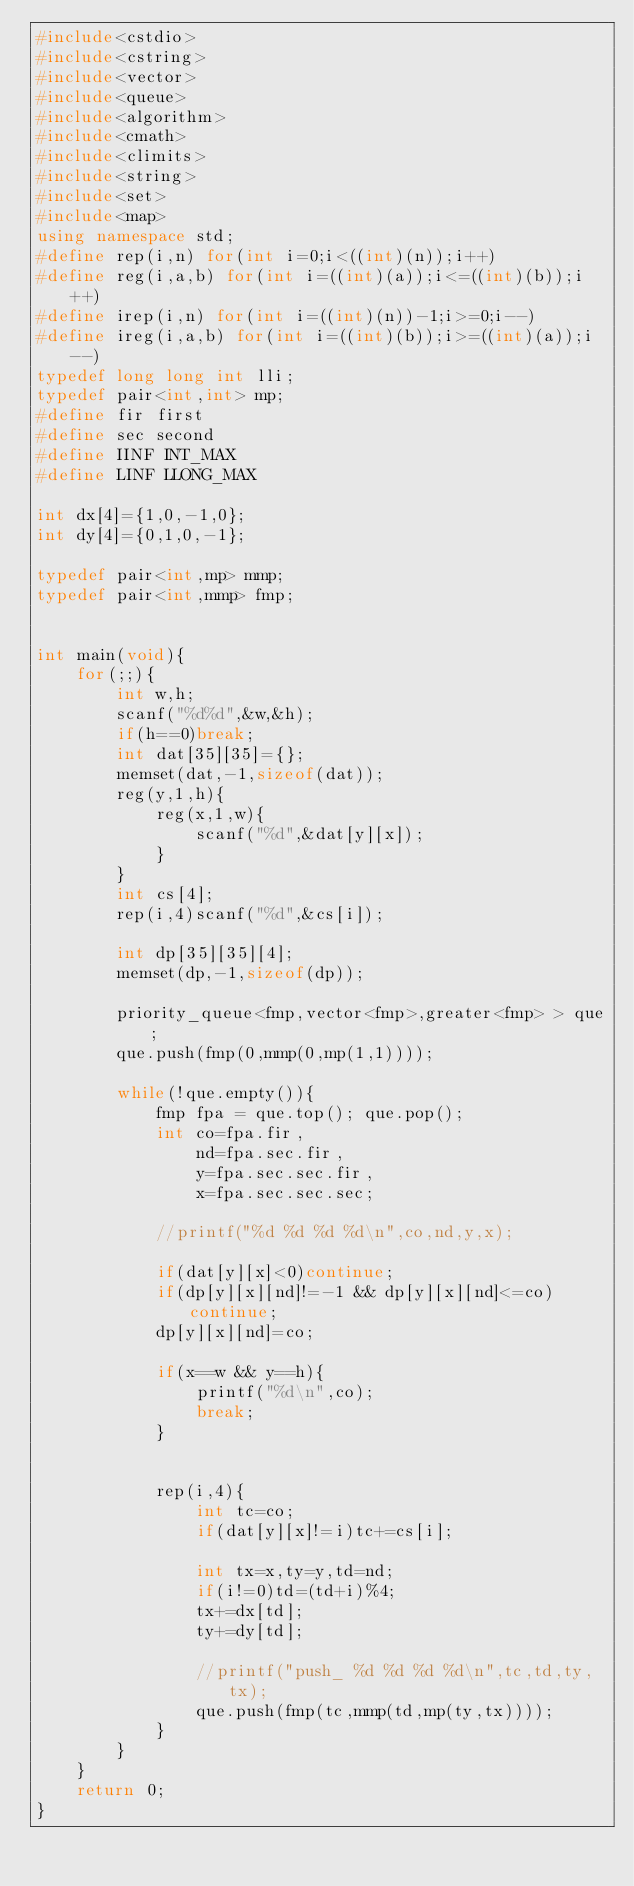Convert code to text. <code><loc_0><loc_0><loc_500><loc_500><_C++_>#include<cstdio>
#include<cstring>
#include<vector>
#include<queue>
#include<algorithm>
#include<cmath>
#include<climits>
#include<string>
#include<set>
#include<map>
using namespace std;
#define rep(i,n) for(int i=0;i<((int)(n));i++)
#define reg(i,a,b) for(int i=((int)(a));i<=((int)(b));i++)
#define irep(i,n) for(int i=((int)(n))-1;i>=0;i--)
#define ireg(i,a,b) for(int i=((int)(b));i>=((int)(a));i--)
typedef long long int lli;
typedef pair<int,int> mp;
#define fir first
#define sec second
#define IINF INT_MAX
#define LINF LLONG_MAX

int dx[4]={1,0,-1,0};
int dy[4]={0,1,0,-1};

typedef pair<int,mp> mmp;
typedef pair<int,mmp> fmp;


int main(void){
	for(;;){
		int w,h;
		scanf("%d%d",&w,&h);
		if(h==0)break;
		int dat[35][35]={};
		memset(dat,-1,sizeof(dat));
		reg(y,1,h){
			reg(x,1,w){
				scanf("%d",&dat[y][x]);
			}
		}
		int cs[4];
		rep(i,4)scanf("%d",&cs[i]);
		
		int dp[35][35][4];
		memset(dp,-1,sizeof(dp));
		
		priority_queue<fmp,vector<fmp>,greater<fmp> > que;
		que.push(fmp(0,mmp(0,mp(1,1))));
		
		while(!que.empty()){
			fmp fpa = que.top(); que.pop();
			int co=fpa.fir,
				nd=fpa.sec.fir,
				y=fpa.sec.sec.fir,
				x=fpa.sec.sec.sec;
			
			//printf("%d %d %d %d\n",co,nd,y,x);
			
			if(dat[y][x]<0)continue;
			if(dp[y][x][nd]!=-1 && dp[y][x][nd]<=co)continue;
			dp[y][x][nd]=co;
			
			if(x==w && y==h){
				printf("%d\n",co);
				break;
			}
			
			
			rep(i,4){
				int tc=co;
				if(dat[y][x]!=i)tc+=cs[i];
				
				int tx=x,ty=y,td=nd;
				if(i!=0)td=(td+i)%4;
				tx+=dx[td];
				ty+=dy[td];
				
				//printf("push_ %d %d %d %d\n",tc,td,ty,tx);
				que.push(fmp(tc,mmp(td,mp(ty,tx))));
			}
		}
	}
	return 0;
}</code> 